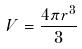<formula> <loc_0><loc_0><loc_500><loc_500>V = \frac { 4 \pi r ^ { 3 } } { 3 }</formula> 